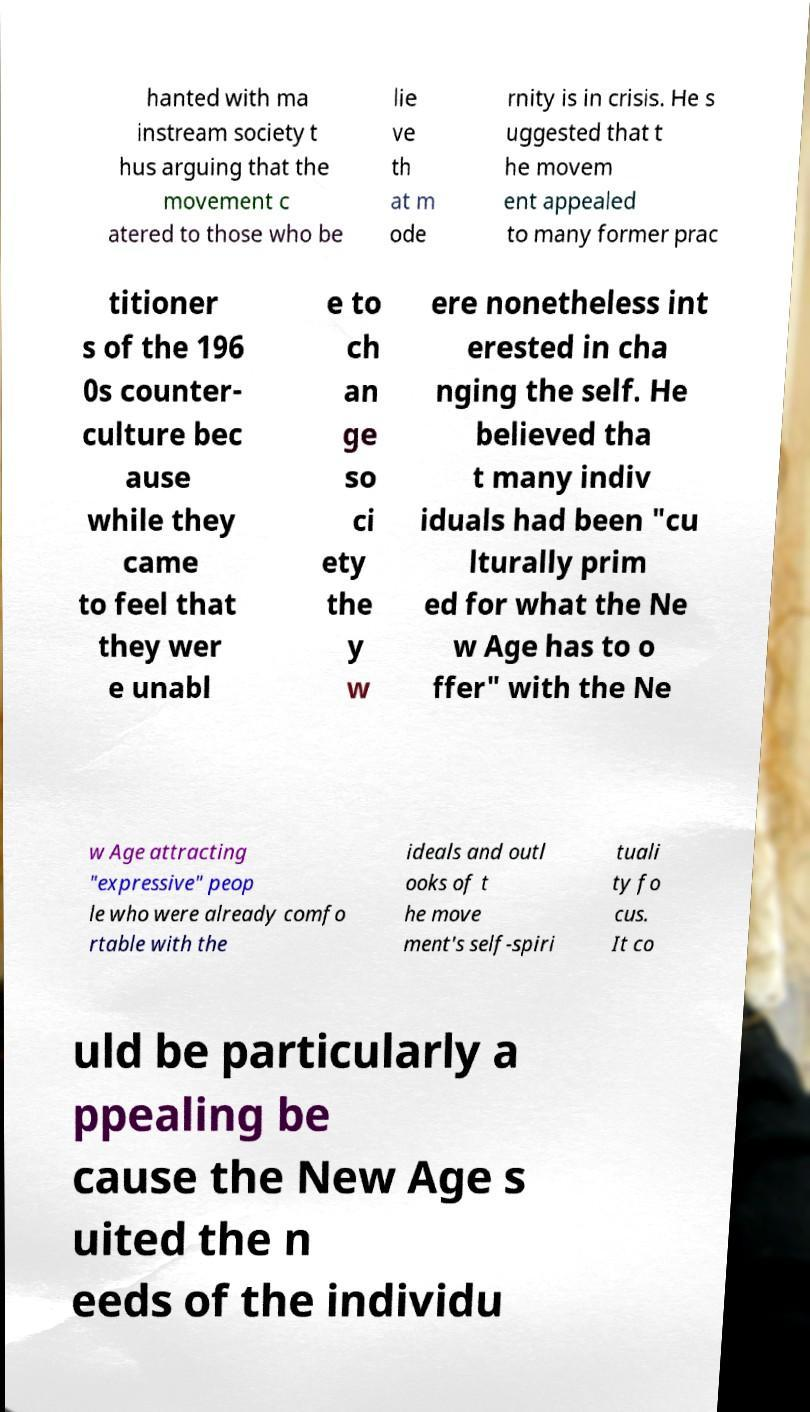Could you assist in decoding the text presented in this image and type it out clearly? hanted with ma instream society t hus arguing that the movement c atered to those who be lie ve th at m ode rnity is in crisis. He s uggested that t he movem ent appealed to many former prac titioner s of the 196 0s counter- culture bec ause while they came to feel that they wer e unabl e to ch an ge so ci ety the y w ere nonetheless int erested in cha nging the self. He believed tha t many indiv iduals had been "cu lturally prim ed for what the Ne w Age has to o ffer" with the Ne w Age attracting "expressive" peop le who were already comfo rtable with the ideals and outl ooks of t he move ment's self-spiri tuali ty fo cus. It co uld be particularly a ppealing be cause the New Age s uited the n eeds of the individu 